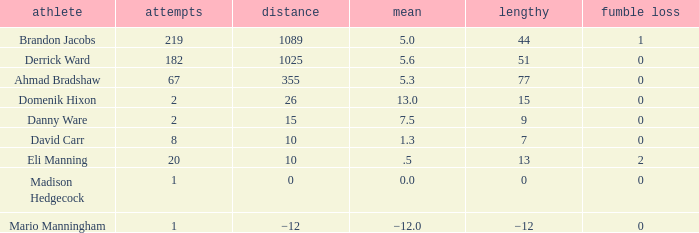Could you parse the entire table? {'header': ['athlete', 'attempts', 'distance', 'mean', 'lengthy', 'fumble loss'], 'rows': [['Brandon Jacobs', '219', '1089', '5.0', '44', '1'], ['Derrick Ward', '182', '1025', '5.6', '51', '0'], ['Ahmad Bradshaw', '67', '355', '5.3', '77', '0'], ['Domenik Hixon', '2', '26', '13.0', '15', '0'], ['Danny Ware', '2', '15', '7.5', '9', '0'], ['David Carr', '8', '10', '1.3', '7', '0'], ['Eli Manning', '20', '10', '.5', '13', '2'], ['Madison Hedgecock', '1', '0', '0.0', '0', '0'], ['Mario Manningham', '1', '−12', '−12.0', '−12', '0']]} What is Domenik Hixon's average rush? 13.0. 